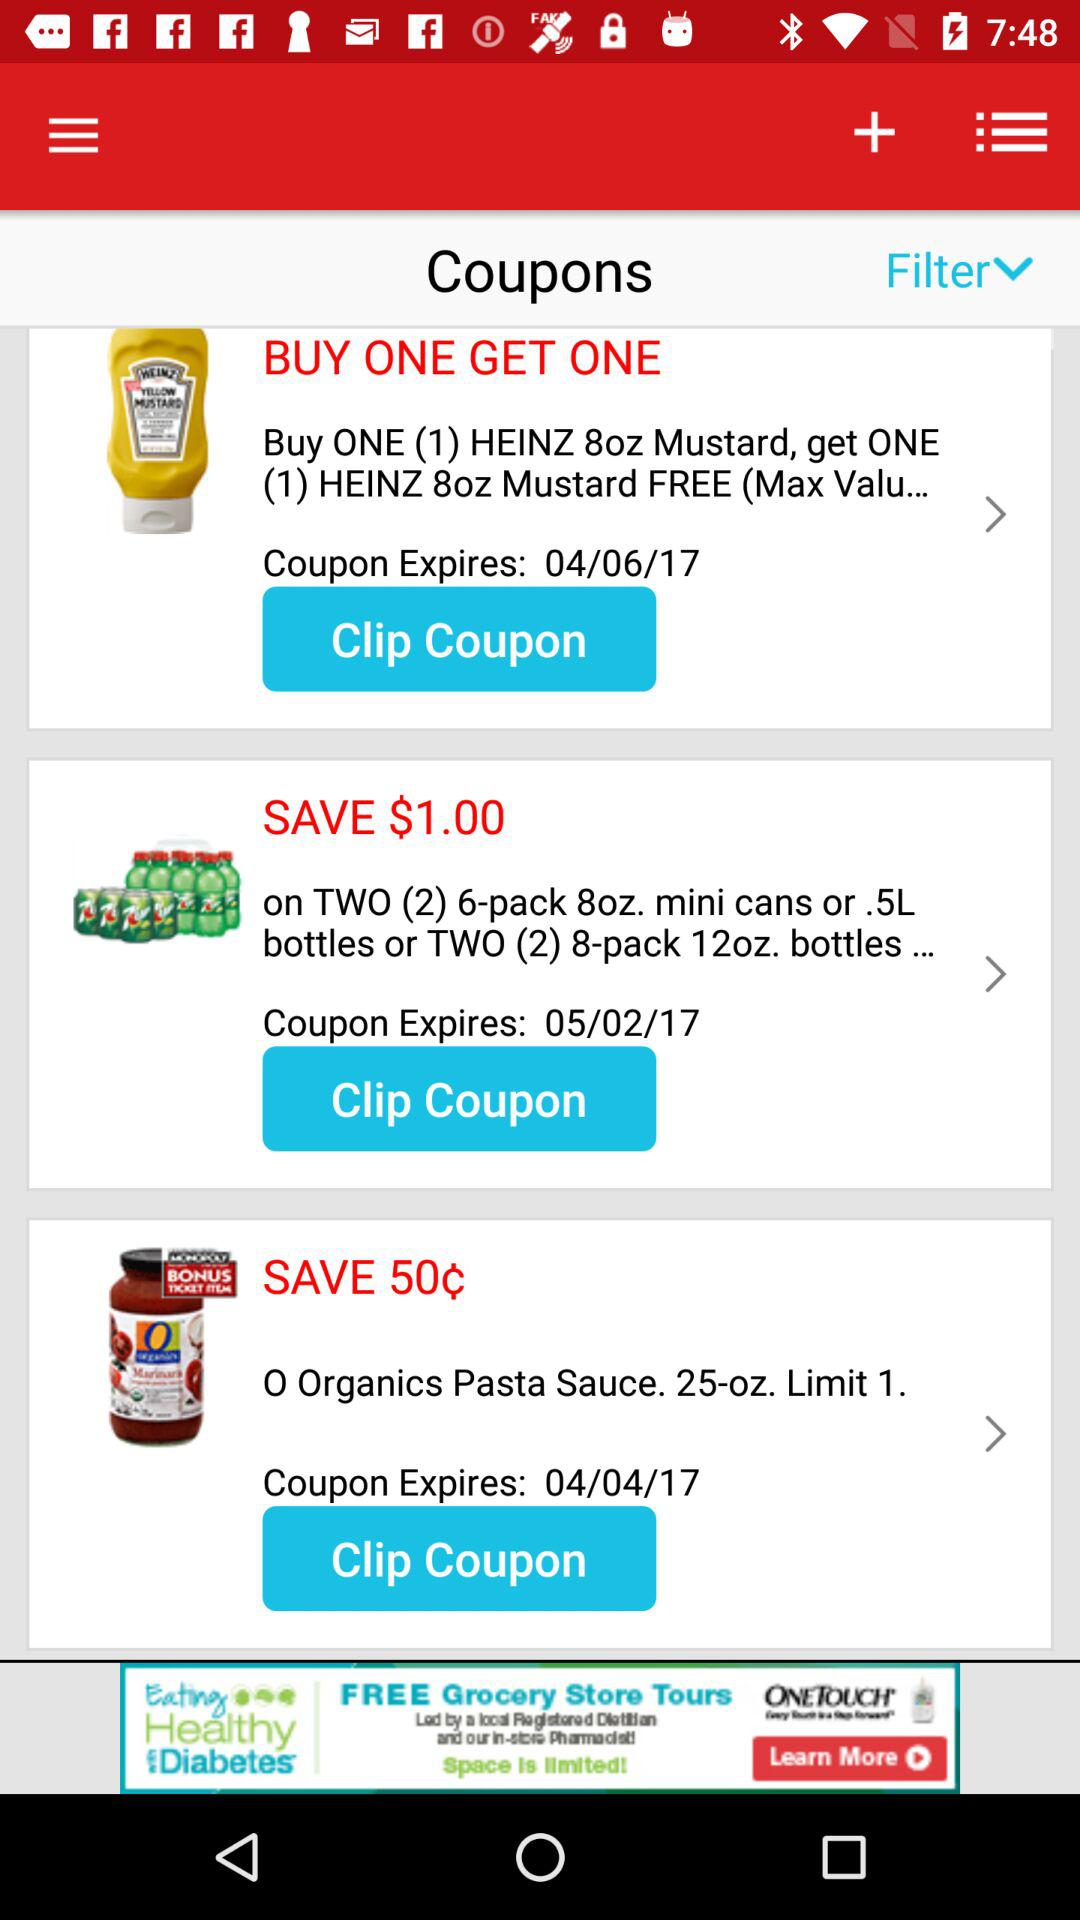How many coupons are there?
Answer the question using a single word or phrase. 3 